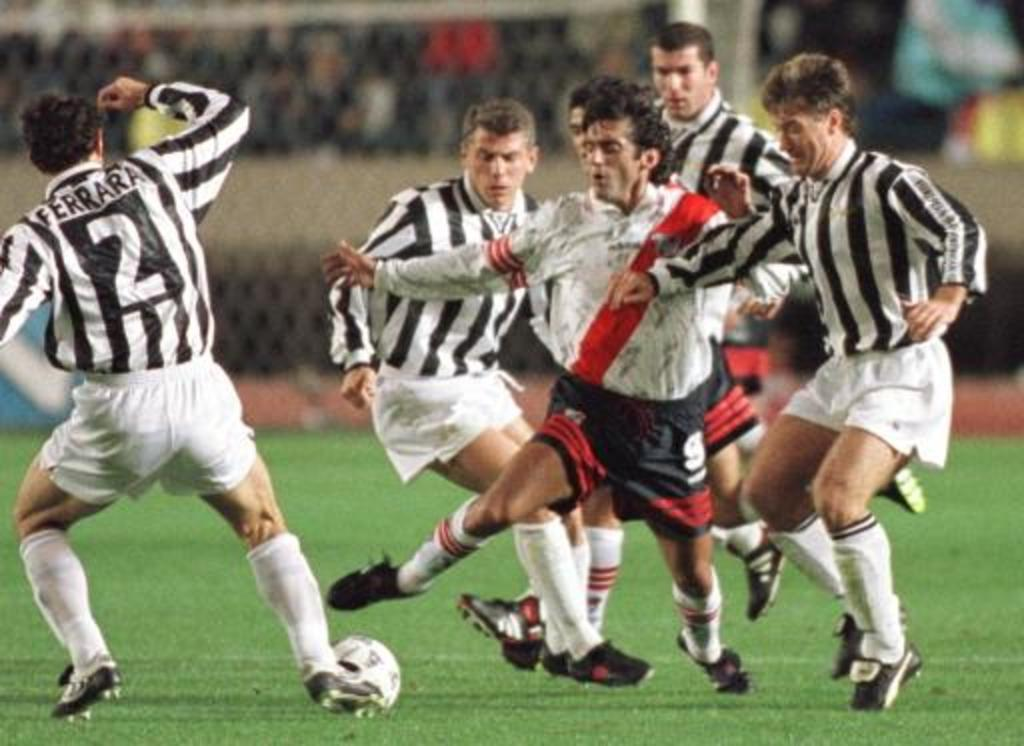<image>
Offer a succinct explanation of the picture presented. Several soccer players run up to steal the ball from number 2. 